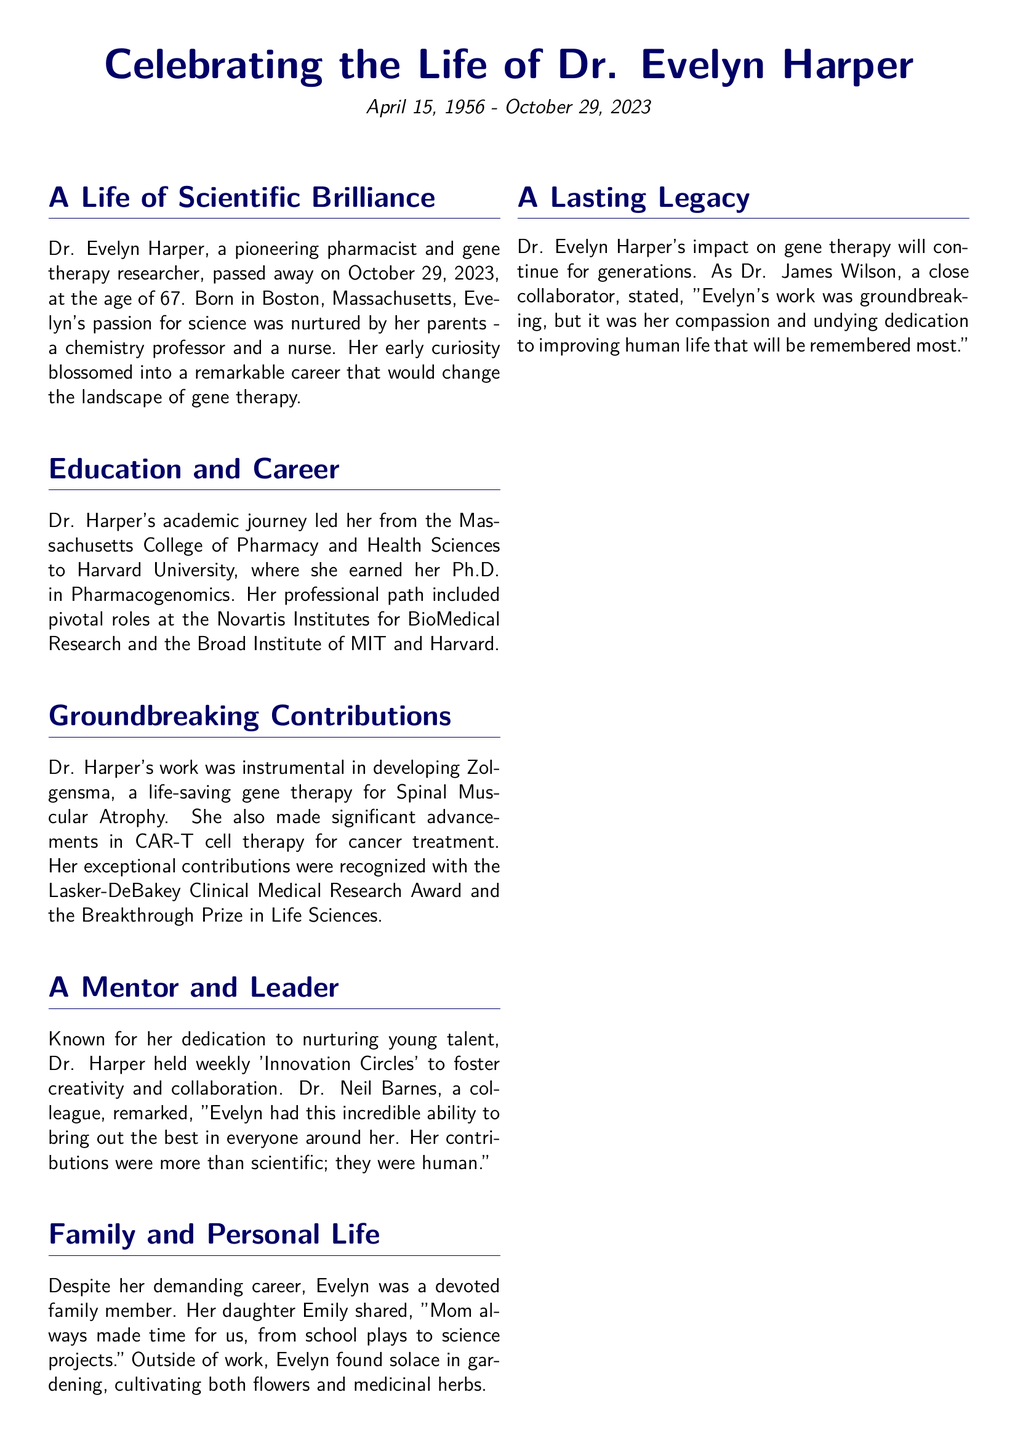What was the date of Dr. Evelyn Harper's passing? The document states that Dr. Evelyn Harper passed away on October 29, 2023.
Answer: October 29, 2023 Where did Dr. Harper earn her Ph.D.? The document mentions that Dr. Harper earned her Ph.D. in Pharmacogenomics at Harvard University.
Answer: Harvard University What life-saving gene therapy did Dr. Harper help develop? The document identifies Zolgensma as the life-saving gene therapy developed by Dr. Harper.
Answer: Zolgensma Which award did Dr. Harper receive in 2019? The document lists the Lasker-DeBakey Clinical Medical Research Award as an award received by Dr. Harper in 2019.
Answer: Lasker-DeBakey Clinical Medical Research Award How many children does Dr. Harper have? The document mentions that Dr. Harper has two children, Emily and Michael.
Answer: Two What was the purpose of 'Innovation Circles' held by Dr. Harper? The document explains that 'Innovation Circles' were meant to foster creativity and collaboration among young talent.
Answer: Foster creativity and collaboration Which profession did Dr. Harper's parents have? The document states that her father was a chemistry professor and her mother was a nurse.
Answer: Chemistry professor and nurse What is mentioned as a personal pastime of Dr. Harper? The document notes that Dr. Harper found solace in gardening, including cultivating medicinal herbs.
Answer: Gardening 